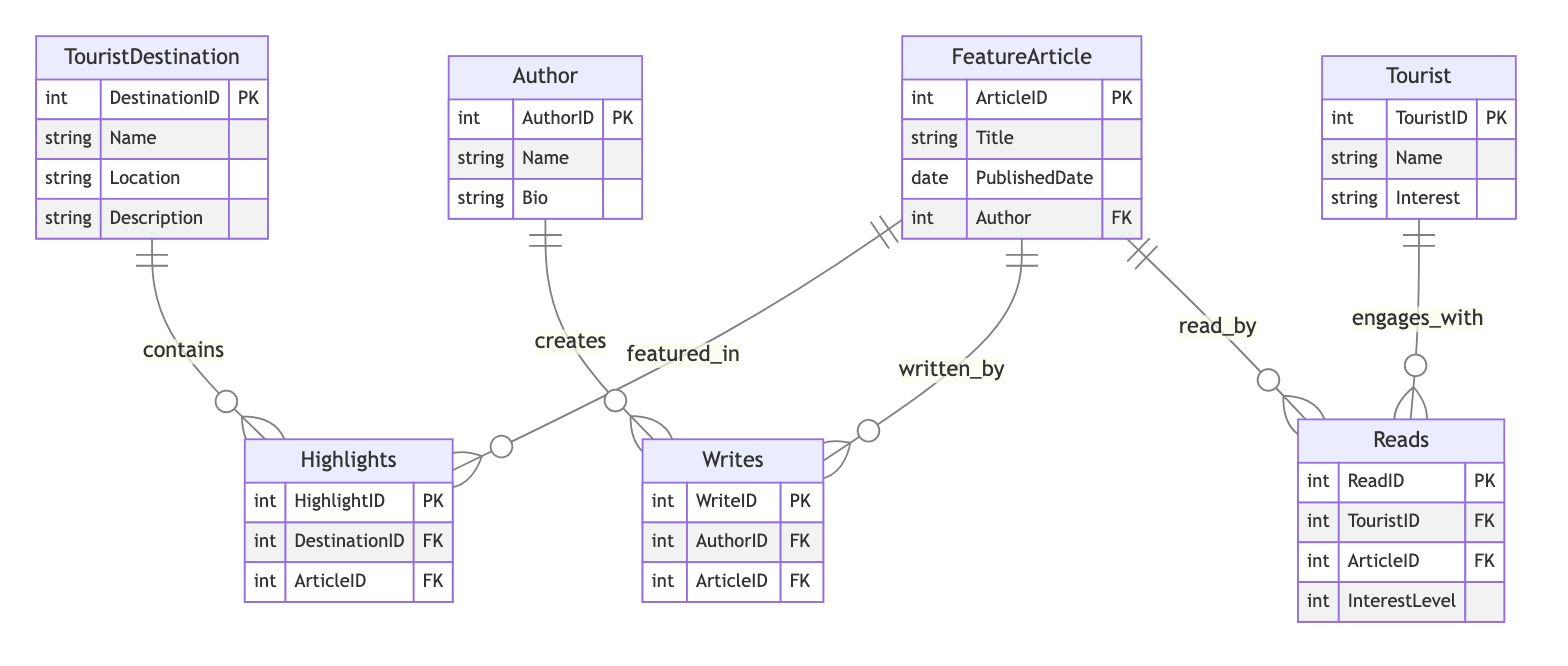What are the attributes of the TouristDestination entity? The TouristDestination entity has the attributes: DestinationID, Name, Location, and Description as specified in the diagram.
Answer: DestinationID, Name, Location, Description How many entities are defined in the diagram? There are four entities in the diagram: TouristDestination, FeatureArticle, Author, and Tourist. Counting them provides the total number of entities.
Answer: 4 What relationship connects FeatureArticle and Author? The Writes relationship connects FeatureArticle and Author, indicating that authors write feature articles as per the relationship stated in the diagram.
Answer: Writes Does a Tourist read FeatureArticles? Yes, the Reads relationship shows that a Tourist engages with FeatureArticles, indicating that tourists can read articles about destinations.
Answer: Yes What is the maximum number of FeaturesArticles that one Author can write? The diagram indicates that each Author can write multiple FeatureArticles based on the Writes relationship, but does not specify any upper limit, implying a potential maximum of many.
Answer: Many How many attributes are there in the FeatureArticle entity? The FeatureArticle entity contains four attributes: ArticleID, Title, PublishedDate, and Author, as defined in the entity’s specifications.
Answer: 4 Is there a direct relationship between Tourist and TouristDestination? No, the diagram does not indicate a direct relationship between Tourist and TouristDestination; the relationships are made through FeatureArticles.
Answer: No What does the Reads relationship and its attributes signify? The Reads relationship signifies that tourists read articles, and it has attributes ReadID and InterestLevel, indicating who read what and their level of interest in the article.
Answer: Reads, ReadID, InterestLevel Which entity has a bio attribute? The Author entity has a Bio attribute defined, which provides additional information about the author in the context of the diagram.
Answer: Author 